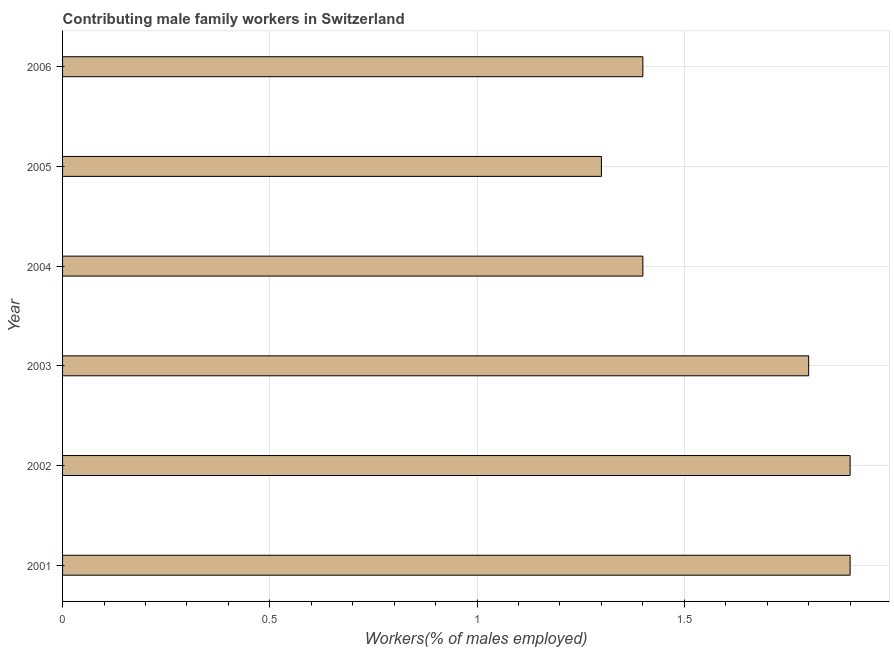Does the graph contain any zero values?
Offer a very short reply. No. What is the title of the graph?
Make the answer very short. Contributing male family workers in Switzerland. What is the label or title of the X-axis?
Give a very brief answer. Workers(% of males employed). What is the contributing male family workers in 2005?
Keep it short and to the point. 1.3. Across all years, what is the maximum contributing male family workers?
Provide a succinct answer. 1.9. Across all years, what is the minimum contributing male family workers?
Ensure brevity in your answer.  1.3. In which year was the contributing male family workers maximum?
Keep it short and to the point. 2001. What is the sum of the contributing male family workers?
Offer a terse response. 9.7. What is the difference between the contributing male family workers in 2001 and 2003?
Give a very brief answer. 0.1. What is the average contributing male family workers per year?
Ensure brevity in your answer.  1.62. What is the median contributing male family workers?
Keep it short and to the point. 1.6. In how many years, is the contributing male family workers greater than 1.7 %?
Provide a short and direct response. 3. What is the ratio of the contributing male family workers in 2004 to that in 2005?
Your answer should be very brief. 1.08. Is the difference between the contributing male family workers in 2002 and 2003 greater than the difference between any two years?
Ensure brevity in your answer.  No. What is the difference between the highest and the lowest contributing male family workers?
Provide a succinct answer. 0.6. In how many years, is the contributing male family workers greater than the average contributing male family workers taken over all years?
Offer a very short reply. 3. Are all the bars in the graph horizontal?
Keep it short and to the point. Yes. How many years are there in the graph?
Give a very brief answer. 6. What is the difference between two consecutive major ticks on the X-axis?
Your response must be concise. 0.5. What is the Workers(% of males employed) in 2001?
Provide a short and direct response. 1.9. What is the Workers(% of males employed) in 2002?
Your answer should be compact. 1.9. What is the Workers(% of males employed) of 2003?
Keep it short and to the point. 1.8. What is the Workers(% of males employed) of 2004?
Your response must be concise. 1.4. What is the Workers(% of males employed) of 2005?
Give a very brief answer. 1.3. What is the Workers(% of males employed) of 2006?
Your answer should be very brief. 1.4. What is the difference between the Workers(% of males employed) in 2001 and 2003?
Give a very brief answer. 0.1. What is the difference between the Workers(% of males employed) in 2001 and 2004?
Your answer should be very brief. 0.5. What is the difference between the Workers(% of males employed) in 2001 and 2005?
Provide a succinct answer. 0.6. What is the difference between the Workers(% of males employed) in 2001 and 2006?
Give a very brief answer. 0.5. What is the difference between the Workers(% of males employed) in 2002 and 2003?
Offer a terse response. 0.1. What is the difference between the Workers(% of males employed) in 2002 and 2004?
Keep it short and to the point. 0.5. What is the difference between the Workers(% of males employed) in 2002 and 2005?
Keep it short and to the point. 0.6. What is the difference between the Workers(% of males employed) in 2002 and 2006?
Offer a very short reply. 0.5. What is the difference between the Workers(% of males employed) in 2003 and 2004?
Your answer should be very brief. 0.4. What is the difference between the Workers(% of males employed) in 2003 and 2006?
Keep it short and to the point. 0.4. What is the difference between the Workers(% of males employed) in 2004 and 2005?
Provide a succinct answer. 0.1. What is the difference between the Workers(% of males employed) in 2004 and 2006?
Offer a very short reply. 0. What is the ratio of the Workers(% of males employed) in 2001 to that in 2002?
Keep it short and to the point. 1. What is the ratio of the Workers(% of males employed) in 2001 to that in 2003?
Your answer should be very brief. 1.06. What is the ratio of the Workers(% of males employed) in 2001 to that in 2004?
Your answer should be very brief. 1.36. What is the ratio of the Workers(% of males employed) in 2001 to that in 2005?
Ensure brevity in your answer.  1.46. What is the ratio of the Workers(% of males employed) in 2001 to that in 2006?
Provide a short and direct response. 1.36. What is the ratio of the Workers(% of males employed) in 2002 to that in 2003?
Make the answer very short. 1.06. What is the ratio of the Workers(% of males employed) in 2002 to that in 2004?
Your response must be concise. 1.36. What is the ratio of the Workers(% of males employed) in 2002 to that in 2005?
Offer a terse response. 1.46. What is the ratio of the Workers(% of males employed) in 2002 to that in 2006?
Make the answer very short. 1.36. What is the ratio of the Workers(% of males employed) in 2003 to that in 2004?
Provide a short and direct response. 1.29. What is the ratio of the Workers(% of males employed) in 2003 to that in 2005?
Keep it short and to the point. 1.39. What is the ratio of the Workers(% of males employed) in 2003 to that in 2006?
Provide a succinct answer. 1.29. What is the ratio of the Workers(% of males employed) in 2004 to that in 2005?
Offer a terse response. 1.08. What is the ratio of the Workers(% of males employed) in 2004 to that in 2006?
Keep it short and to the point. 1. What is the ratio of the Workers(% of males employed) in 2005 to that in 2006?
Offer a very short reply. 0.93. 